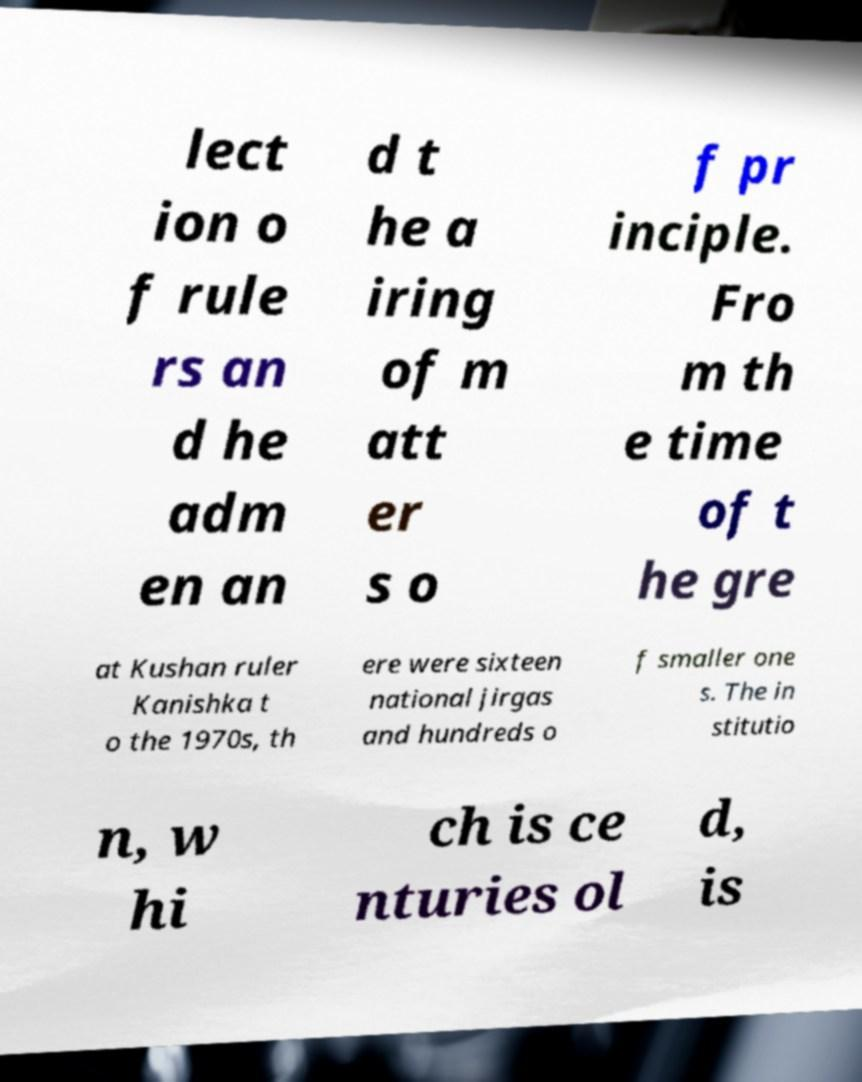Can you accurately transcribe the text from the provided image for me? lect ion o f rule rs an d he adm en an d t he a iring of m att er s o f pr inciple. Fro m th e time of t he gre at Kushan ruler Kanishka t o the 1970s, th ere were sixteen national jirgas and hundreds o f smaller one s. The in stitutio n, w hi ch is ce nturies ol d, is 